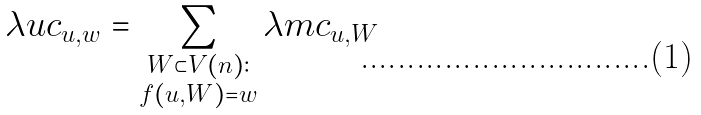<formula> <loc_0><loc_0><loc_500><loc_500>\lambda u c _ { u , w } = \sum _ { \substack { W \subset V ( n ) \colon \\ f ( u , W ) = w } } \lambda m c _ { u , W }</formula> 